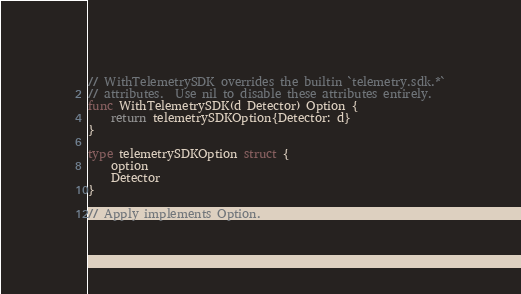Convert code to text. <code><loc_0><loc_0><loc_500><loc_500><_Go_>// WithTelemetrySDK overrides the builtin `telemetry.sdk.*`
// attributes.  Use nil to disable these attributes entirely.
func WithTelemetrySDK(d Detector) Option {
	return telemetrySDKOption{Detector: d}
}

type telemetrySDKOption struct {
	option
	Detector
}

// Apply implements Option.</code> 